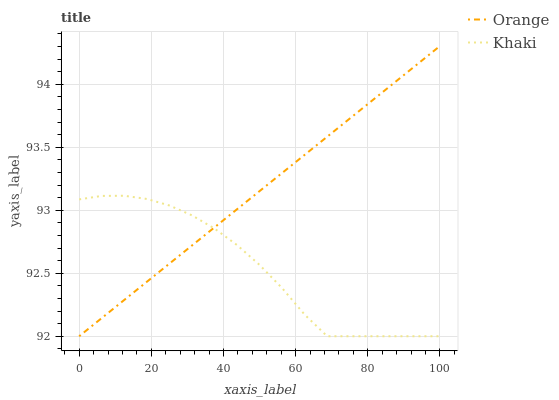Does Khaki have the minimum area under the curve?
Answer yes or no. Yes. Does Orange have the maximum area under the curve?
Answer yes or no. Yes. Does Khaki have the maximum area under the curve?
Answer yes or no. No. Is Orange the smoothest?
Answer yes or no. Yes. Is Khaki the roughest?
Answer yes or no. Yes. Is Khaki the smoothest?
Answer yes or no. No. Does Orange have the lowest value?
Answer yes or no. Yes. Does Orange have the highest value?
Answer yes or no. Yes. Does Khaki have the highest value?
Answer yes or no. No. Does Orange intersect Khaki?
Answer yes or no. Yes. Is Orange less than Khaki?
Answer yes or no. No. Is Orange greater than Khaki?
Answer yes or no. No. 